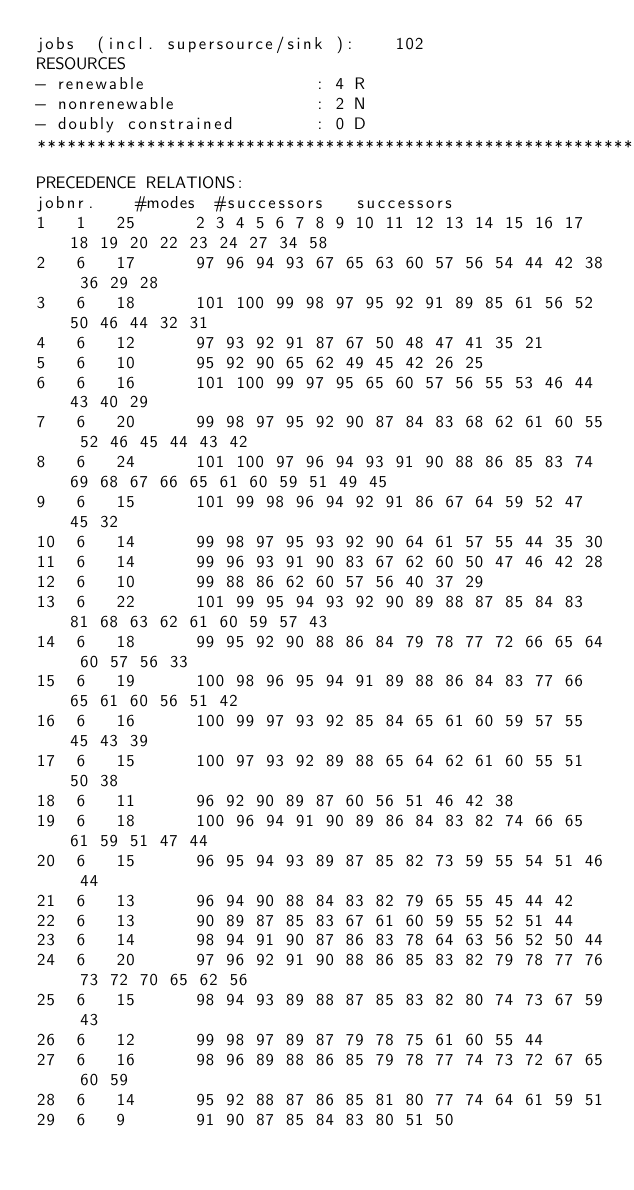<code> <loc_0><loc_0><loc_500><loc_500><_ObjectiveC_>jobs  (incl. supersource/sink ):	102
RESOURCES
- renewable                 : 4 R
- nonrenewable              : 2 N
- doubly constrained        : 0 D
************************************************************************
PRECEDENCE RELATIONS:
jobnr.    #modes  #successors   successors
1	1	25		2 3 4 5 6 7 8 9 10 11 12 13 14 15 16 17 18 19 20 22 23 24 27 34 58 
2	6	17		97 96 94 93 67 65 63 60 57 56 54 44 42 38 36 29 28 
3	6	18		101 100 99 98 97 95 92 91 89 85 61 56 52 50 46 44 32 31 
4	6	12		97 93 92 91 87 67 50 48 47 41 35 21 
5	6	10		95 92 90 65 62 49 45 42 26 25 
6	6	16		101 100 99 97 95 65 60 57 56 55 53 46 44 43 40 29 
7	6	20		99 98 97 95 92 90 87 84 83 68 62 61 60 55 52 46 45 44 43 42 
8	6	24		101 100 97 96 94 93 91 90 88 86 85 83 74 69 68 67 66 65 61 60 59 51 49 45 
9	6	15		101 99 98 96 94 92 91 86 67 64 59 52 47 45 32 
10	6	14		99 98 97 95 93 92 90 64 61 57 55 44 35 30 
11	6	14		99 96 93 91 90 83 67 62 60 50 47 46 42 28 
12	6	10		99 88 86 62 60 57 56 40 37 29 
13	6	22		101 99 95 94 93 92 90 89 88 87 85 84 83 81 68 63 62 61 60 59 57 43 
14	6	18		99 95 92 90 88 86 84 79 78 77 72 66 65 64 60 57 56 33 
15	6	19		100 98 96 95 94 91 89 88 86 84 83 77 66 65 61 60 56 51 42 
16	6	16		100 99 97 93 92 85 84 65 61 60 59 57 55 45 43 39 
17	6	15		100 97 93 92 89 88 65 64 62 61 60 55 51 50 38 
18	6	11		96 92 90 89 87 60 56 51 46 42 38 
19	6	18		100 96 94 91 90 89 86 84 83 82 74 66 65 61 59 51 47 44 
20	6	15		96 95 94 93 89 87 85 82 73 59 55 54 51 46 44 
21	6	13		96 94 90 88 84 83 82 79 65 55 45 44 42 
22	6	13		90 89 87 85 83 67 61 60 59 55 52 51 44 
23	6	14		98 94 91 90 87 86 83 78 64 63 56 52 50 44 
24	6	20		97 96 92 91 90 88 86 85 83 82 79 78 77 76 73 72 70 65 62 56 
25	6	15		98 94 93 89 88 87 85 83 82 80 74 73 67 59 43 
26	6	12		99 98 97 89 87 79 78 75 61 60 55 44 
27	6	16		98 96 89 88 86 85 79 78 77 74 73 72 67 65 60 59 
28	6	14		95 92 88 87 86 85 81 80 77 74 64 61 59 51 
29	6	9		91 90 87 85 84 83 80 51 50 </code> 